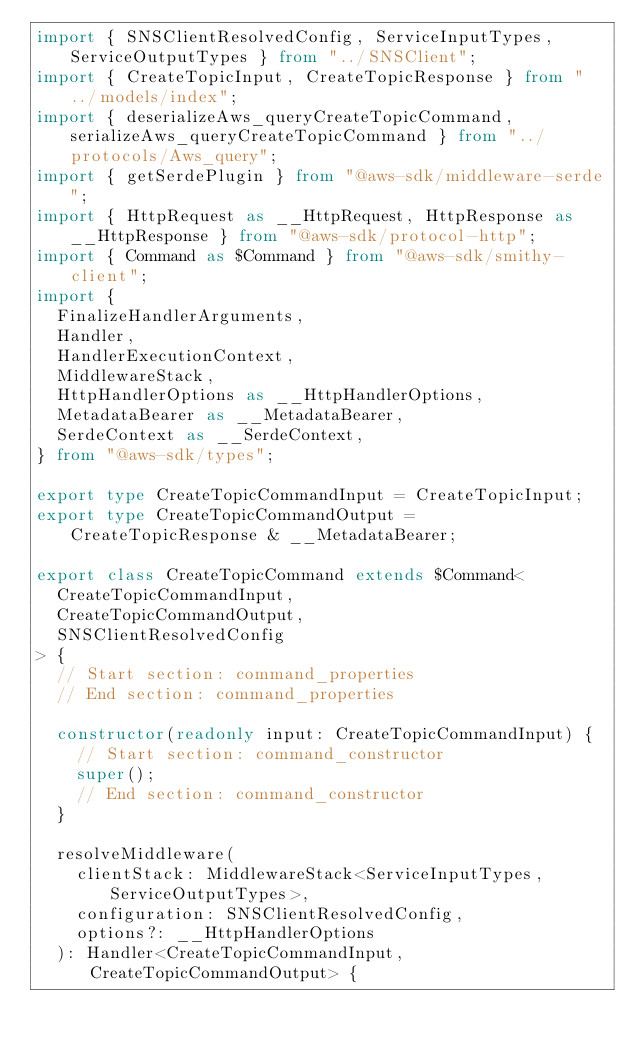<code> <loc_0><loc_0><loc_500><loc_500><_TypeScript_>import { SNSClientResolvedConfig, ServiceInputTypes, ServiceOutputTypes } from "../SNSClient";
import { CreateTopicInput, CreateTopicResponse } from "../models/index";
import { deserializeAws_queryCreateTopicCommand, serializeAws_queryCreateTopicCommand } from "../protocols/Aws_query";
import { getSerdePlugin } from "@aws-sdk/middleware-serde";
import { HttpRequest as __HttpRequest, HttpResponse as __HttpResponse } from "@aws-sdk/protocol-http";
import { Command as $Command } from "@aws-sdk/smithy-client";
import {
  FinalizeHandlerArguments,
  Handler,
  HandlerExecutionContext,
  MiddlewareStack,
  HttpHandlerOptions as __HttpHandlerOptions,
  MetadataBearer as __MetadataBearer,
  SerdeContext as __SerdeContext,
} from "@aws-sdk/types";

export type CreateTopicCommandInput = CreateTopicInput;
export type CreateTopicCommandOutput = CreateTopicResponse & __MetadataBearer;

export class CreateTopicCommand extends $Command<
  CreateTopicCommandInput,
  CreateTopicCommandOutput,
  SNSClientResolvedConfig
> {
  // Start section: command_properties
  // End section: command_properties

  constructor(readonly input: CreateTopicCommandInput) {
    // Start section: command_constructor
    super();
    // End section: command_constructor
  }

  resolveMiddleware(
    clientStack: MiddlewareStack<ServiceInputTypes, ServiceOutputTypes>,
    configuration: SNSClientResolvedConfig,
    options?: __HttpHandlerOptions
  ): Handler<CreateTopicCommandInput, CreateTopicCommandOutput> {</code> 